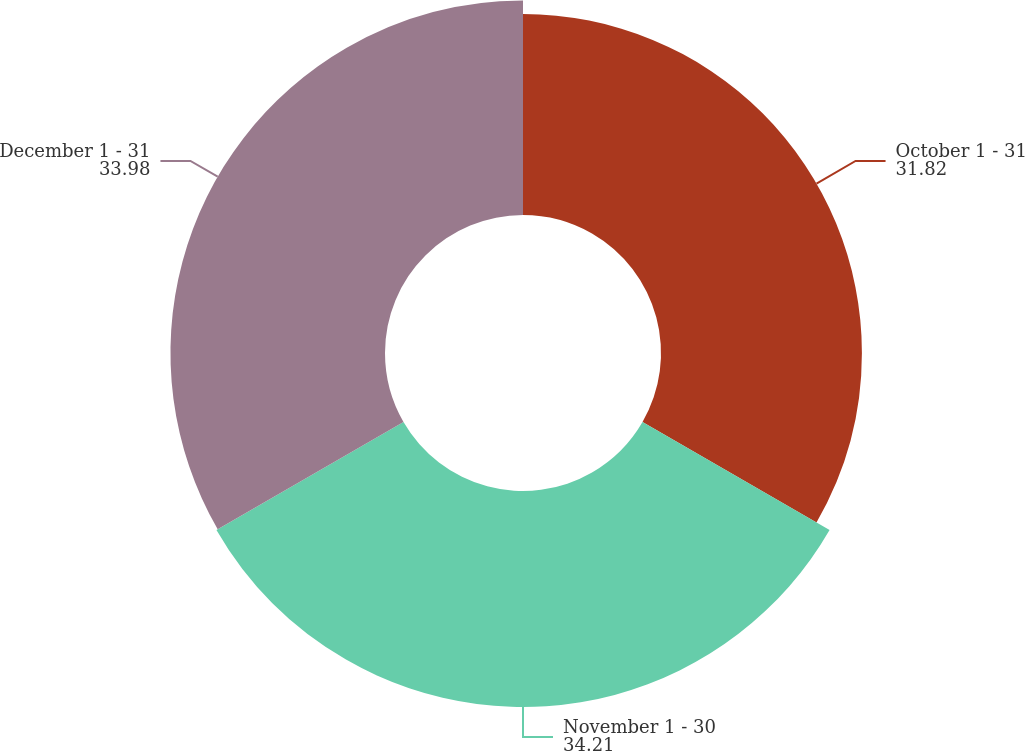Convert chart to OTSL. <chart><loc_0><loc_0><loc_500><loc_500><pie_chart><fcel>October 1 - 31<fcel>November 1 - 30<fcel>December 1 - 31<nl><fcel>31.82%<fcel>34.21%<fcel>33.98%<nl></chart> 